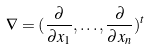<formula> <loc_0><loc_0><loc_500><loc_500>\nabla = ( \frac { \partial } { \partial x _ { 1 } } , \dots , \frac { \partial } { \partial x _ { n } } ) ^ { t }</formula> 